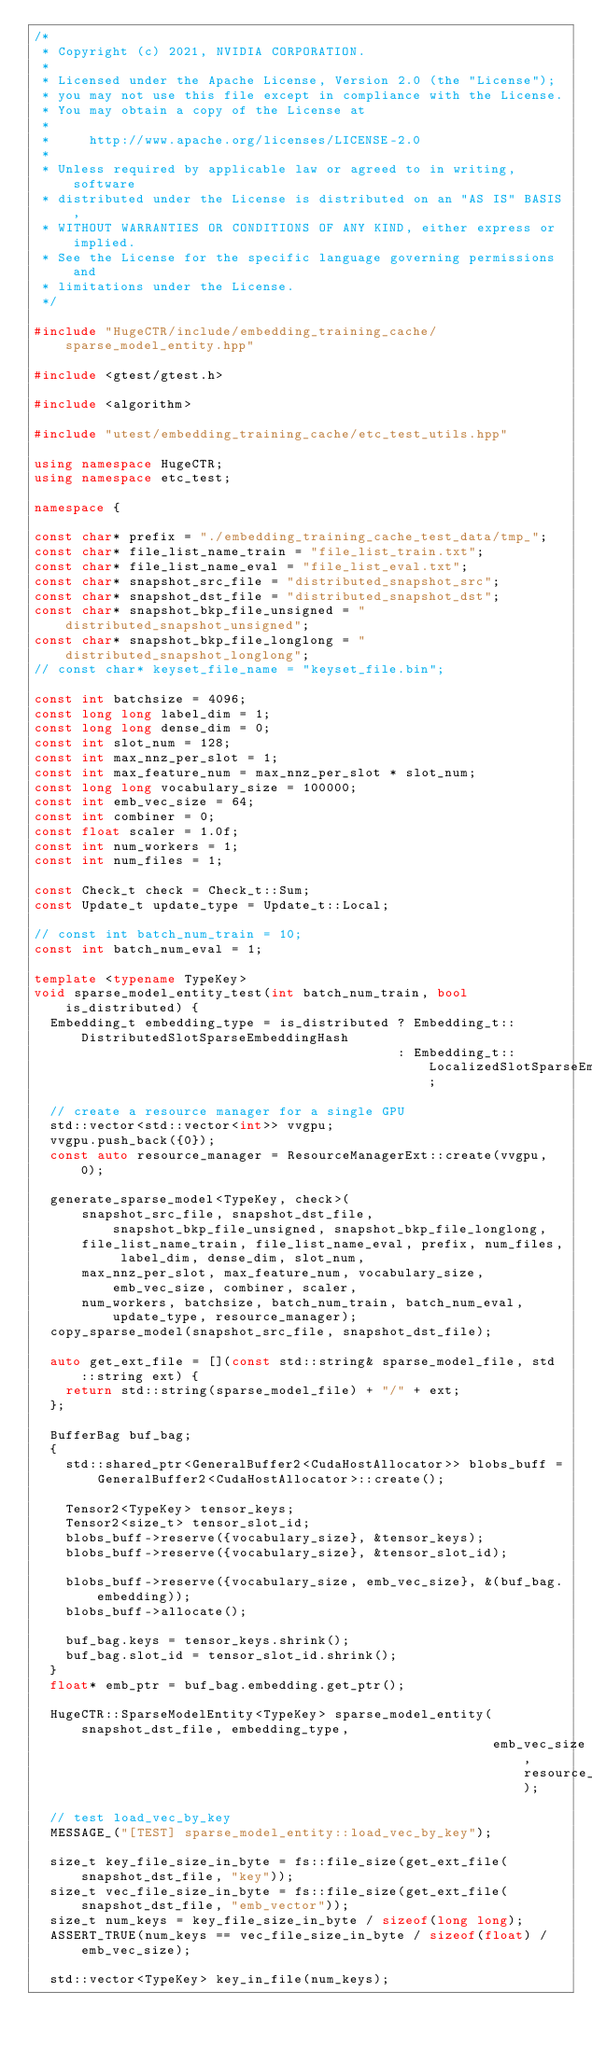<code> <loc_0><loc_0><loc_500><loc_500><_C++_>/*
 * Copyright (c) 2021, NVIDIA CORPORATION.
 *
 * Licensed under the Apache License, Version 2.0 (the "License");
 * you may not use this file except in compliance with the License.
 * You may obtain a copy of the License at
 *
 *     http://www.apache.org/licenses/LICENSE-2.0
 *
 * Unless required by applicable law or agreed to in writing, software
 * distributed under the License is distributed on an "AS IS" BASIS,
 * WITHOUT WARRANTIES OR CONDITIONS OF ANY KIND, either express or implied.
 * See the License for the specific language governing permissions and
 * limitations under the License.
 */

#include "HugeCTR/include/embedding_training_cache/sparse_model_entity.hpp"

#include <gtest/gtest.h>

#include <algorithm>

#include "utest/embedding_training_cache/etc_test_utils.hpp"

using namespace HugeCTR;
using namespace etc_test;

namespace {

const char* prefix = "./embedding_training_cache_test_data/tmp_";
const char* file_list_name_train = "file_list_train.txt";
const char* file_list_name_eval = "file_list_eval.txt";
const char* snapshot_src_file = "distributed_snapshot_src";
const char* snapshot_dst_file = "distributed_snapshot_dst";
const char* snapshot_bkp_file_unsigned = "distributed_snapshot_unsigned";
const char* snapshot_bkp_file_longlong = "distributed_snapshot_longlong";
// const char* keyset_file_name = "keyset_file.bin";

const int batchsize = 4096;
const long long label_dim = 1;
const long long dense_dim = 0;
const int slot_num = 128;
const int max_nnz_per_slot = 1;
const int max_feature_num = max_nnz_per_slot * slot_num;
const long long vocabulary_size = 100000;
const int emb_vec_size = 64;
const int combiner = 0;
const float scaler = 1.0f;
const int num_workers = 1;
const int num_files = 1;

const Check_t check = Check_t::Sum;
const Update_t update_type = Update_t::Local;

// const int batch_num_train = 10;
const int batch_num_eval = 1;

template <typename TypeKey>
void sparse_model_entity_test(int batch_num_train, bool is_distributed) {
  Embedding_t embedding_type = is_distributed ? Embedding_t::DistributedSlotSparseEmbeddingHash
                                              : Embedding_t::LocalizedSlotSparseEmbeddingHash;

  // create a resource manager for a single GPU
  std::vector<std::vector<int>> vvgpu;
  vvgpu.push_back({0});
  const auto resource_manager = ResourceManagerExt::create(vvgpu, 0);

  generate_sparse_model<TypeKey, check>(
      snapshot_src_file, snapshot_dst_file, snapshot_bkp_file_unsigned, snapshot_bkp_file_longlong,
      file_list_name_train, file_list_name_eval, prefix, num_files, label_dim, dense_dim, slot_num,
      max_nnz_per_slot, max_feature_num, vocabulary_size, emb_vec_size, combiner, scaler,
      num_workers, batchsize, batch_num_train, batch_num_eval, update_type, resource_manager);
  copy_sparse_model(snapshot_src_file, snapshot_dst_file);

  auto get_ext_file = [](const std::string& sparse_model_file, std::string ext) {
    return std::string(sparse_model_file) + "/" + ext;
  };

  BufferBag buf_bag;
  {
    std::shared_ptr<GeneralBuffer2<CudaHostAllocator>> blobs_buff =
        GeneralBuffer2<CudaHostAllocator>::create();

    Tensor2<TypeKey> tensor_keys;
    Tensor2<size_t> tensor_slot_id;
    blobs_buff->reserve({vocabulary_size}, &tensor_keys);
    blobs_buff->reserve({vocabulary_size}, &tensor_slot_id);

    blobs_buff->reserve({vocabulary_size, emb_vec_size}, &(buf_bag.embedding));
    blobs_buff->allocate();

    buf_bag.keys = tensor_keys.shrink();
    buf_bag.slot_id = tensor_slot_id.shrink();
  }
  float* emb_ptr = buf_bag.embedding.get_ptr();

  HugeCTR::SparseModelEntity<TypeKey> sparse_model_entity(snapshot_dst_file, embedding_type,
                                                          emb_vec_size, resource_manager);

  // test load_vec_by_key
  MESSAGE_("[TEST] sparse_model_entity::load_vec_by_key");

  size_t key_file_size_in_byte = fs::file_size(get_ext_file(snapshot_dst_file, "key"));
  size_t vec_file_size_in_byte = fs::file_size(get_ext_file(snapshot_dst_file, "emb_vector"));
  size_t num_keys = key_file_size_in_byte / sizeof(long long);
  ASSERT_TRUE(num_keys == vec_file_size_in_byte / sizeof(float) / emb_vec_size);

  std::vector<TypeKey> key_in_file(num_keys);</code> 